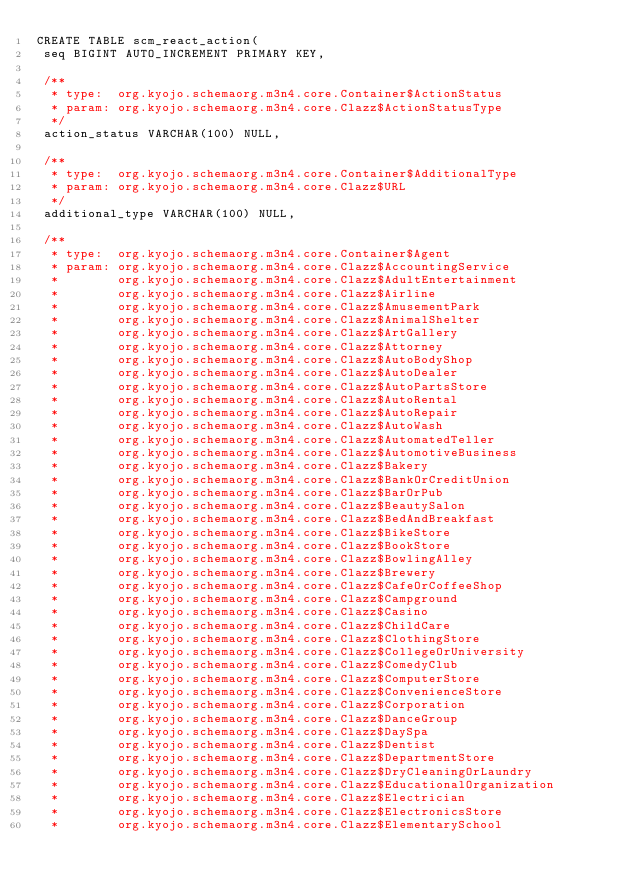Convert code to text. <code><loc_0><loc_0><loc_500><loc_500><_SQL_>CREATE TABLE scm_react_action(
 seq BIGINT AUTO_INCREMENT PRIMARY KEY,

 /**
  * type:  org.kyojo.schemaorg.m3n4.core.Container$ActionStatus
  * param: org.kyojo.schemaorg.m3n4.core.Clazz$ActionStatusType
  */
 action_status VARCHAR(100) NULL,

 /**
  * type:  org.kyojo.schemaorg.m3n4.core.Container$AdditionalType
  * param: org.kyojo.schemaorg.m3n4.core.Clazz$URL
  */
 additional_type VARCHAR(100) NULL,

 /**
  * type:  org.kyojo.schemaorg.m3n4.core.Container$Agent
  * param: org.kyojo.schemaorg.m3n4.core.Clazz$AccountingService
  *        org.kyojo.schemaorg.m3n4.core.Clazz$AdultEntertainment
  *        org.kyojo.schemaorg.m3n4.core.Clazz$Airline
  *        org.kyojo.schemaorg.m3n4.core.Clazz$AmusementPark
  *        org.kyojo.schemaorg.m3n4.core.Clazz$AnimalShelter
  *        org.kyojo.schemaorg.m3n4.core.Clazz$ArtGallery
  *        org.kyojo.schemaorg.m3n4.core.Clazz$Attorney
  *        org.kyojo.schemaorg.m3n4.core.Clazz$AutoBodyShop
  *        org.kyojo.schemaorg.m3n4.core.Clazz$AutoDealer
  *        org.kyojo.schemaorg.m3n4.core.Clazz$AutoPartsStore
  *        org.kyojo.schemaorg.m3n4.core.Clazz$AutoRental
  *        org.kyojo.schemaorg.m3n4.core.Clazz$AutoRepair
  *        org.kyojo.schemaorg.m3n4.core.Clazz$AutoWash
  *        org.kyojo.schemaorg.m3n4.core.Clazz$AutomatedTeller
  *        org.kyojo.schemaorg.m3n4.core.Clazz$AutomotiveBusiness
  *        org.kyojo.schemaorg.m3n4.core.Clazz$Bakery
  *        org.kyojo.schemaorg.m3n4.core.Clazz$BankOrCreditUnion
  *        org.kyojo.schemaorg.m3n4.core.Clazz$BarOrPub
  *        org.kyojo.schemaorg.m3n4.core.Clazz$BeautySalon
  *        org.kyojo.schemaorg.m3n4.core.Clazz$BedAndBreakfast
  *        org.kyojo.schemaorg.m3n4.core.Clazz$BikeStore
  *        org.kyojo.schemaorg.m3n4.core.Clazz$BookStore
  *        org.kyojo.schemaorg.m3n4.core.Clazz$BowlingAlley
  *        org.kyojo.schemaorg.m3n4.core.Clazz$Brewery
  *        org.kyojo.schemaorg.m3n4.core.Clazz$CafeOrCoffeeShop
  *        org.kyojo.schemaorg.m3n4.core.Clazz$Campground
  *        org.kyojo.schemaorg.m3n4.core.Clazz$Casino
  *        org.kyojo.schemaorg.m3n4.core.Clazz$ChildCare
  *        org.kyojo.schemaorg.m3n4.core.Clazz$ClothingStore
  *        org.kyojo.schemaorg.m3n4.core.Clazz$CollegeOrUniversity
  *        org.kyojo.schemaorg.m3n4.core.Clazz$ComedyClub
  *        org.kyojo.schemaorg.m3n4.core.Clazz$ComputerStore
  *        org.kyojo.schemaorg.m3n4.core.Clazz$ConvenienceStore
  *        org.kyojo.schemaorg.m3n4.core.Clazz$Corporation
  *        org.kyojo.schemaorg.m3n4.core.Clazz$DanceGroup
  *        org.kyojo.schemaorg.m3n4.core.Clazz$DaySpa
  *        org.kyojo.schemaorg.m3n4.core.Clazz$Dentist
  *        org.kyojo.schemaorg.m3n4.core.Clazz$DepartmentStore
  *        org.kyojo.schemaorg.m3n4.core.Clazz$DryCleaningOrLaundry
  *        org.kyojo.schemaorg.m3n4.core.Clazz$EducationalOrganization
  *        org.kyojo.schemaorg.m3n4.core.Clazz$Electrician
  *        org.kyojo.schemaorg.m3n4.core.Clazz$ElectronicsStore
  *        org.kyojo.schemaorg.m3n4.core.Clazz$ElementarySchool</code> 